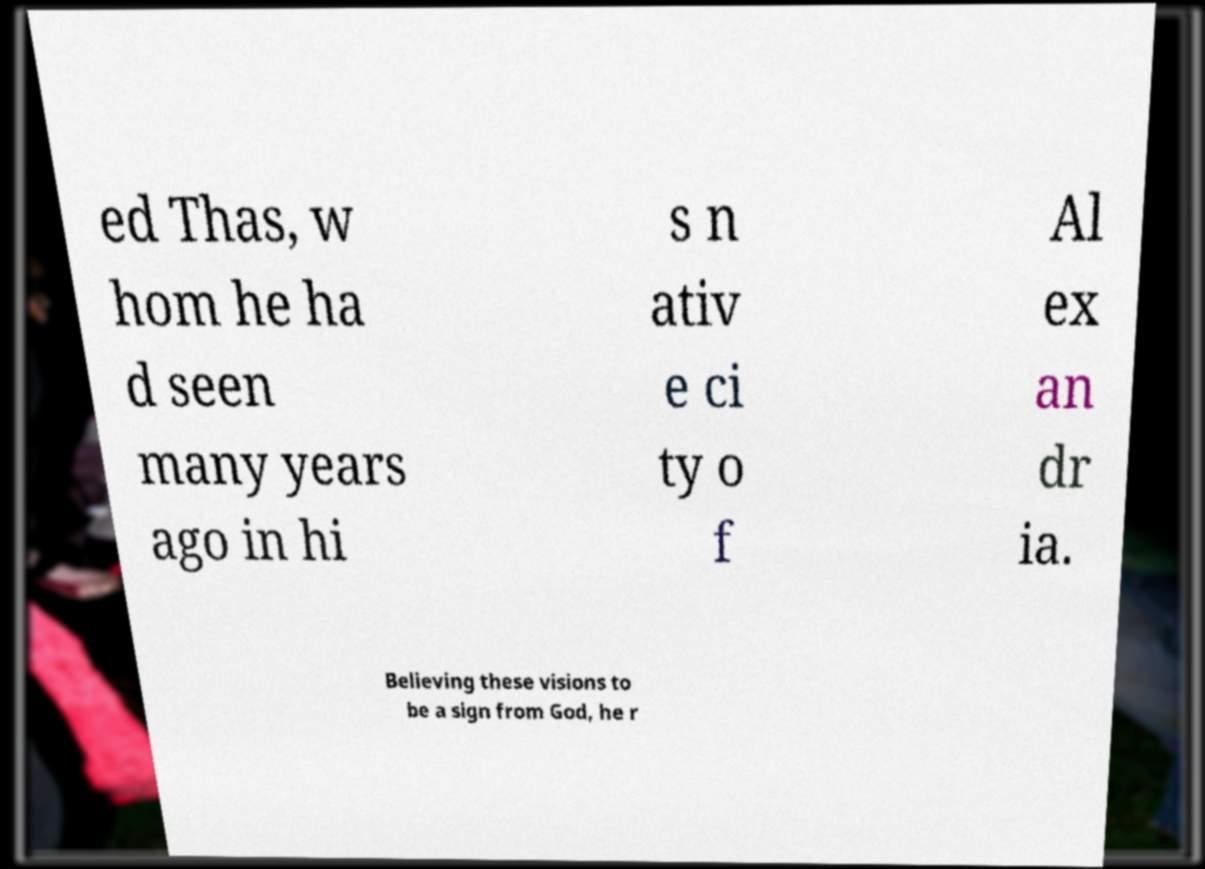Could you assist in decoding the text presented in this image and type it out clearly? ed Thas, w hom he ha d seen many years ago in hi s n ativ e ci ty o f Al ex an dr ia. Believing these visions to be a sign from God, he r 